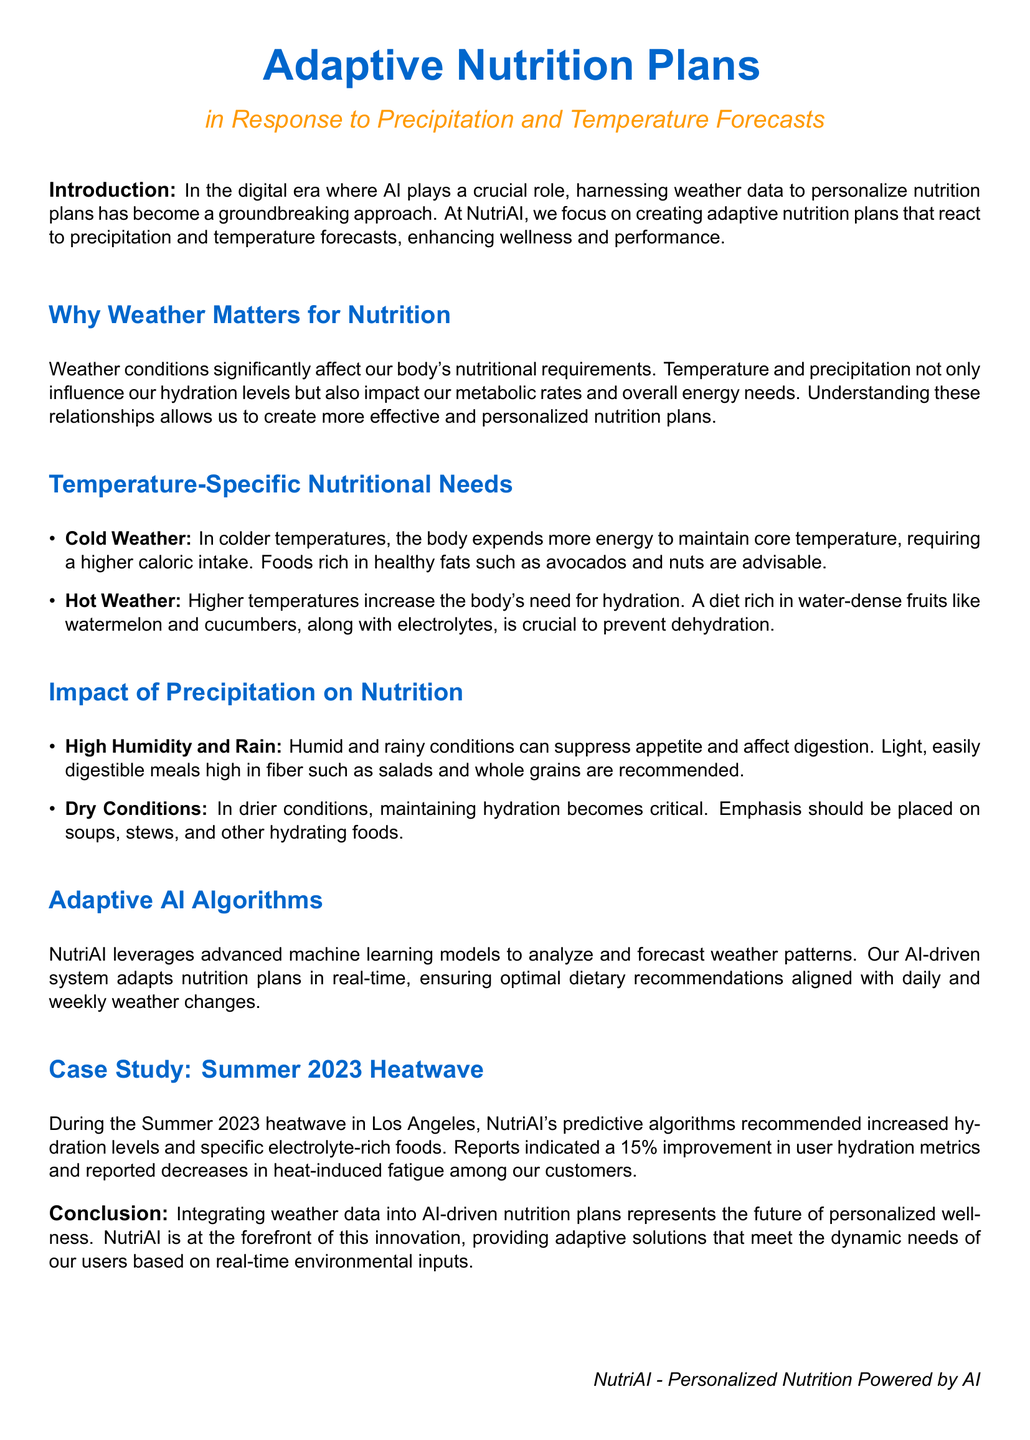What is the title of the report? The title is presented prominently at the top of the document, indicating the focus of the report on adaptive nutrition plans.
Answer: Adaptive Nutrition Plans Why is temperature significant for nutrition? The document explains that temperature impacts nutritional requirements and hydration levels.
Answer: It affects hydration levels and metabolic rates What is recommended for cold weather nutrition? Specific food recommendations for colder temperatures are outlined in the document.
Answer: Foods rich in healthy fats What type of meals are suggested for high humidity conditions? It discusses meal types that are light and easily digestible for high humidity.
Answer: Light, easily digestible meals What kind of foods should be emphasized in dry conditions? The section on dry weather highlights specific types of foods to maintain hydration.
Answer: Soups, stews, and hydrating foods What percentage improvement in hydration metrics was reported during the Summer 2023 heatwave? The case study provides a specific improvement percentage related to hydration.
Answer: 15% What technology does NutriAI use to adapt nutrition plans? The document describes the technological aspect of how nutrition plans are adjusted based on weather.
Answer: Advanced machine learning models What is the conclusion of the report? It summarizes the overall findings and the future direction of integrating weather data into nutrition plans.
Answer: Future of personalized wellness What is the company name mentioned in the report? The report identifies the organization behind the adaptive nutrition plans.
Answer: NutriAI 